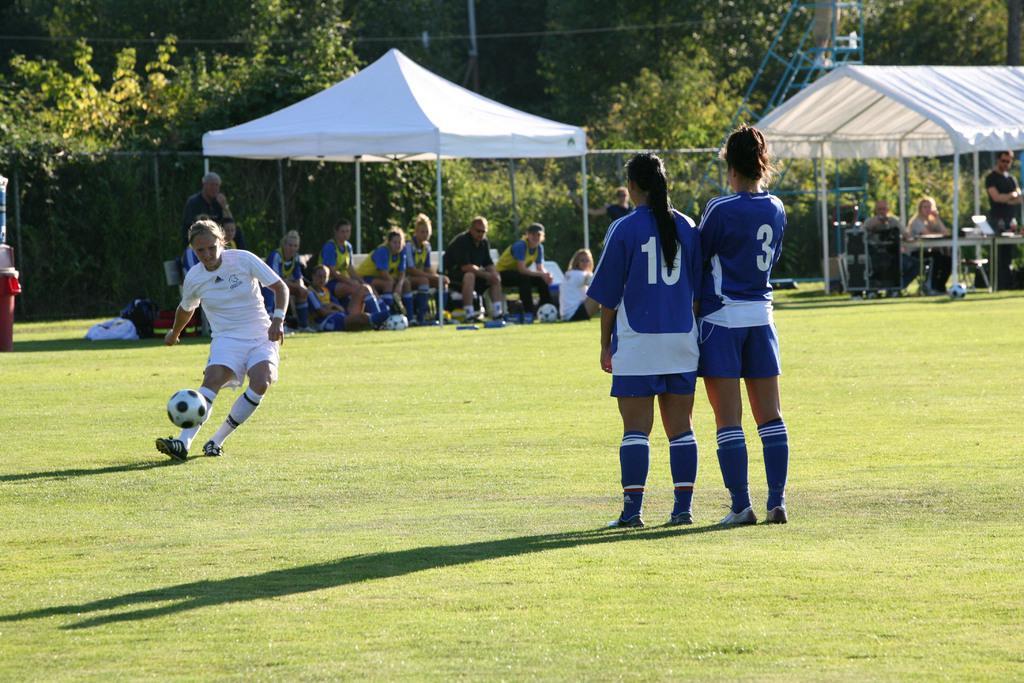Please provide a concise description of this image. In this image I can see group of people, some are sitting and some are standing and I can also see the ball. In the background I can see few tents, the railing and few trees in green color. 